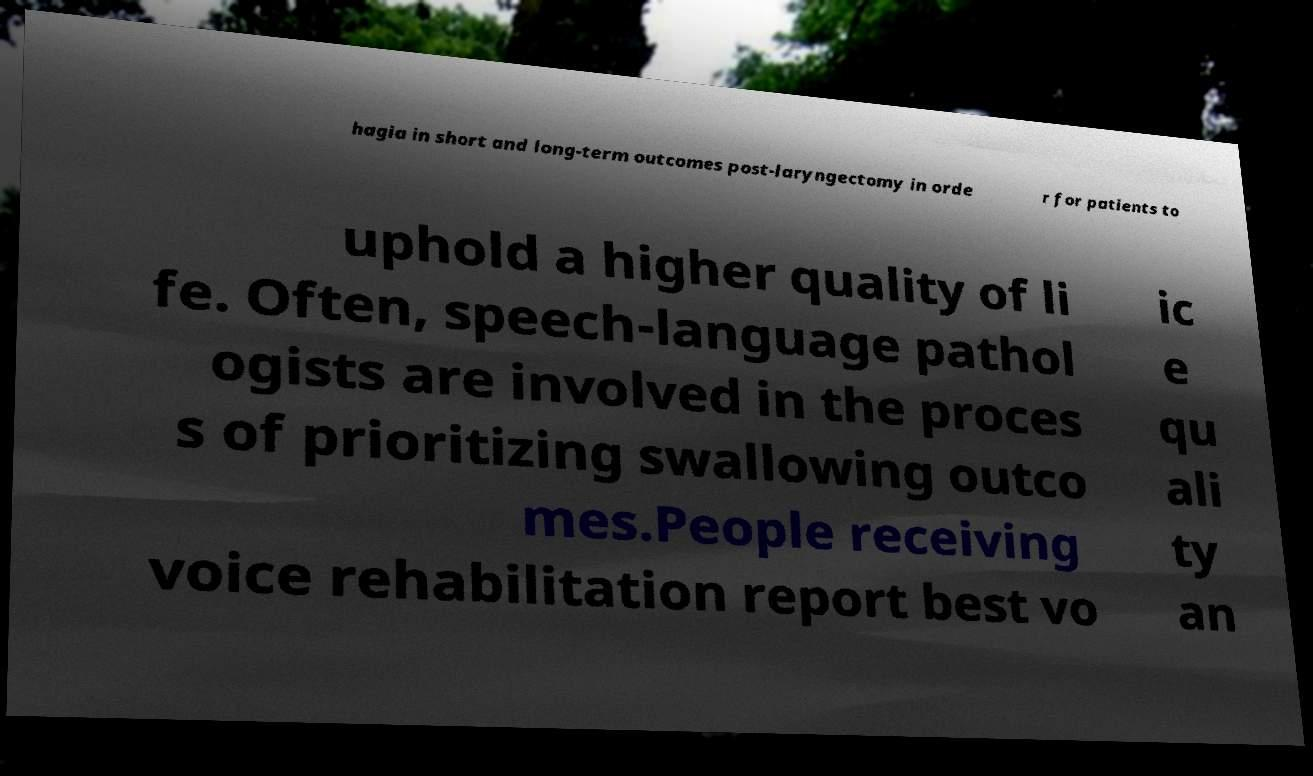There's text embedded in this image that I need extracted. Can you transcribe it verbatim? hagia in short and long-term outcomes post-laryngectomy in orde r for patients to uphold a higher quality of li fe. Often, speech-language pathol ogists are involved in the proces s of prioritizing swallowing outco mes.People receiving voice rehabilitation report best vo ic e qu ali ty an 